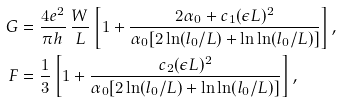Convert formula to latex. <formula><loc_0><loc_0><loc_500><loc_500>G & = \frac { 4 e ^ { 2 } } { \pi h } \, \frac { W } { L } \left [ 1 + \frac { 2 \alpha _ { 0 } + c _ { 1 } ( \epsilon L ) ^ { 2 } } { \alpha _ { 0 } [ 2 \ln ( l _ { 0 } / L ) + \ln \ln ( l _ { 0 } / L ) ] } \right ] , \\ F & = \frac { 1 } { 3 } \left [ 1 + \frac { c _ { 2 } ( \epsilon L ) ^ { 2 } } { \alpha _ { 0 } [ 2 \ln ( l _ { 0 } / L ) + \ln \ln ( l _ { 0 } / L ) ] } \right ] ,</formula> 